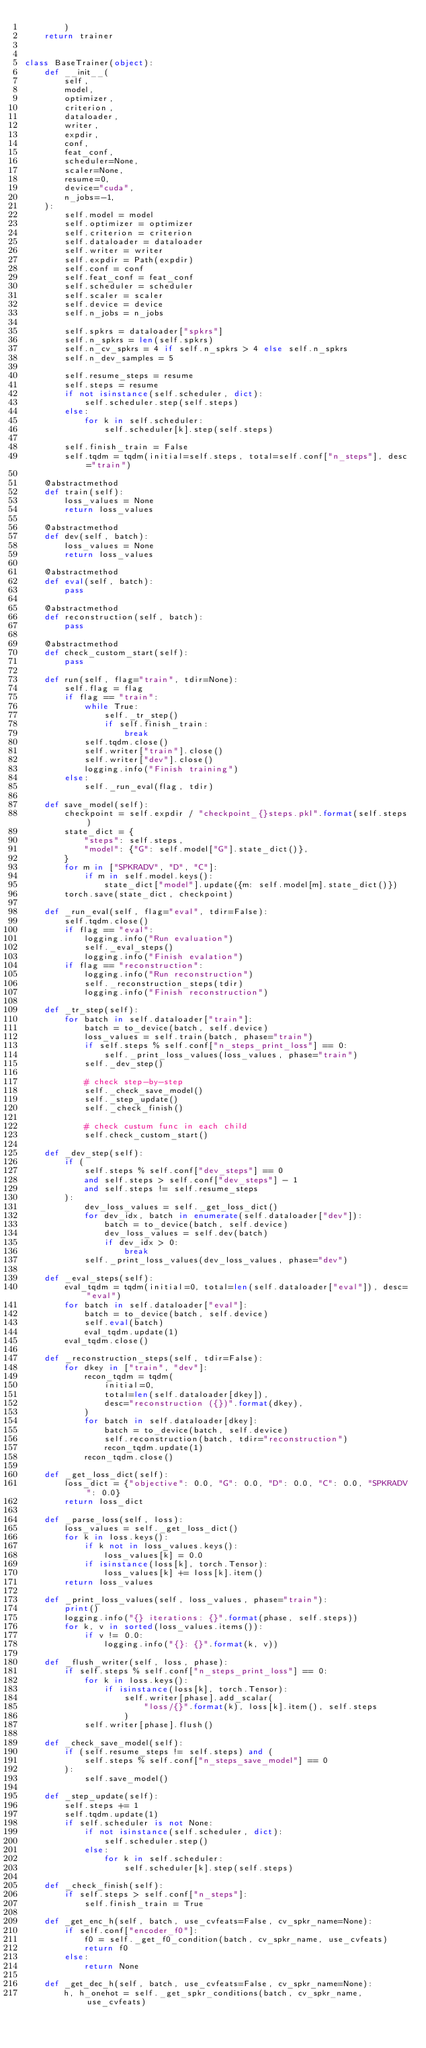<code> <loc_0><loc_0><loc_500><loc_500><_Python_>        )
    return trainer


class BaseTrainer(object):
    def __init__(
        self,
        model,
        optimizer,
        criterion,
        dataloader,
        writer,
        expdir,
        conf,
        feat_conf,
        scheduler=None,
        scaler=None,
        resume=0,
        device="cuda",
        n_jobs=-1,
    ):
        self.model = model
        self.optimizer = optimizer
        self.criterion = criterion
        self.dataloader = dataloader
        self.writer = writer
        self.expdir = Path(expdir)
        self.conf = conf
        self.feat_conf = feat_conf
        self.scheduler = scheduler
        self.scaler = scaler
        self.device = device
        self.n_jobs = n_jobs

        self.spkrs = dataloader["spkrs"]
        self.n_spkrs = len(self.spkrs)
        self.n_cv_spkrs = 4 if self.n_spkrs > 4 else self.n_spkrs
        self.n_dev_samples = 5

        self.resume_steps = resume
        self.steps = resume
        if not isinstance(self.scheduler, dict):
            self.scheduler.step(self.steps)
        else:
            for k in self.scheduler:
                self.scheduler[k].step(self.steps)

        self.finish_train = False
        self.tqdm = tqdm(initial=self.steps, total=self.conf["n_steps"], desc="train")

    @abstractmethod
    def train(self):
        loss_values = None
        return loss_values

    @abstractmethod
    def dev(self, batch):
        loss_values = None
        return loss_values

    @abstractmethod
    def eval(self, batch):
        pass

    @abstractmethod
    def reconstruction(self, batch):
        pass

    @abstractmethod
    def check_custom_start(self):
        pass

    def run(self, flag="train", tdir=None):
        self.flag = flag
        if flag == "train":
            while True:
                self._tr_step()
                if self.finish_train:
                    break
            self.tqdm.close()
            self.writer["train"].close()
            self.writer["dev"].close()
            logging.info("Finish training")
        else:
            self._run_eval(flag, tdir)

    def save_model(self):
        checkpoint = self.expdir / "checkpoint_{}steps.pkl".format(self.steps)
        state_dict = {
            "steps": self.steps,
            "model": {"G": self.model["G"].state_dict()},
        }
        for m in ["SPKRADV", "D", "C"]:
            if m in self.model.keys():
                state_dict["model"].update({m: self.model[m].state_dict()})
        torch.save(state_dict, checkpoint)

    def _run_eval(self, flag="eval", tdir=False):
        self.tqdm.close()
        if flag == "eval":
            logging.info("Run evaluation")
            self._eval_steps()
            logging.info("Finish evalation")
        if flag == "reconstruction":
            logging.info("Run reconstruction")
            self._reconstruction_steps(tdir)
            logging.info("Finish reconstruction")

    def _tr_step(self):
        for batch in self.dataloader["train"]:
            batch = to_device(batch, self.device)
            loss_values = self.train(batch, phase="train")
            if self.steps % self.conf["n_steps_print_loss"] == 0:
                self._print_loss_values(loss_values, phase="train")
            self._dev_step()

            # check step-by-step
            self._check_save_model()
            self._step_update()
            self._check_finish()

            # check custum func in each child
            self.check_custom_start()

    def _dev_step(self):
        if (
            self.steps % self.conf["dev_steps"] == 0
            and self.steps > self.conf["dev_steps"] - 1
            and self.steps != self.resume_steps
        ):
            dev_loss_values = self._get_loss_dict()
            for dev_idx, batch in enumerate(self.dataloader["dev"]):
                batch = to_device(batch, self.device)
                dev_loss_values = self.dev(batch)
                if dev_idx > 0:
                    break
            self._print_loss_values(dev_loss_values, phase="dev")

    def _eval_steps(self):
        eval_tqdm = tqdm(initial=0, total=len(self.dataloader["eval"]), desc="eval")
        for batch in self.dataloader["eval"]:
            batch = to_device(batch, self.device)
            self.eval(batch)
            eval_tqdm.update(1)
        eval_tqdm.close()

    def _reconstruction_steps(self, tdir=False):
        for dkey in ["train", "dev"]:
            recon_tqdm = tqdm(
                initial=0,
                total=len(self.dataloader[dkey]),
                desc="reconstruction ({})".format(dkey),
            )
            for batch in self.dataloader[dkey]:
                batch = to_device(batch, self.device)
                self.reconstruction(batch, tdir="reconstruction")
                recon_tqdm.update(1)
            recon_tqdm.close()

    def _get_loss_dict(self):
        loss_dict = {"objective": 0.0, "G": 0.0, "D": 0.0, "C": 0.0, "SPKRADV": 0.0}
        return loss_dict

    def _parse_loss(self, loss):
        loss_values = self._get_loss_dict()
        for k in loss.keys():
            if k not in loss_values.keys():
                loss_values[k] = 0.0
            if isinstance(loss[k], torch.Tensor):
                loss_values[k] += loss[k].item()
        return loss_values

    def _print_loss_values(self, loss_values, phase="train"):
        print()
        logging.info("{} iterations: {}".format(phase, self.steps))
        for k, v in sorted(loss_values.items()):
            if v != 0.0:
                logging.info("{}: {}".format(k, v))

    def _flush_writer(self, loss, phase):
        if self.steps % self.conf["n_steps_print_loss"] == 0:
            for k in loss.keys():
                if isinstance(loss[k], torch.Tensor):
                    self.writer[phase].add_scalar(
                        "loss/{}".format(k), loss[k].item(), self.steps
                    )
            self.writer[phase].flush()

    def _check_save_model(self):
        if (self.resume_steps != self.steps) and (
            self.steps % self.conf["n_steps_save_model"] == 0
        ):
            self.save_model()

    def _step_update(self):
        self.steps += 1
        self.tqdm.update(1)
        if self.scheduler is not None:
            if not isinstance(self.scheduler, dict):
                self.scheduler.step()
            else:
                for k in self.scheduler:
                    self.scheduler[k].step(self.steps)

    def _check_finish(self):
        if self.steps > self.conf["n_steps"]:
            self.finish_train = True

    def _get_enc_h(self, batch, use_cvfeats=False, cv_spkr_name=None):
        if self.conf["encoder_f0"]:
            f0 = self._get_f0_condition(batch, cv_spkr_name, use_cvfeats)
            return f0
        else:
            return None

    def _get_dec_h(self, batch, use_cvfeats=False, cv_spkr_name=None):
        h, h_onehot = self._get_spkr_conditions(batch, cv_spkr_name, use_cvfeats)</code> 